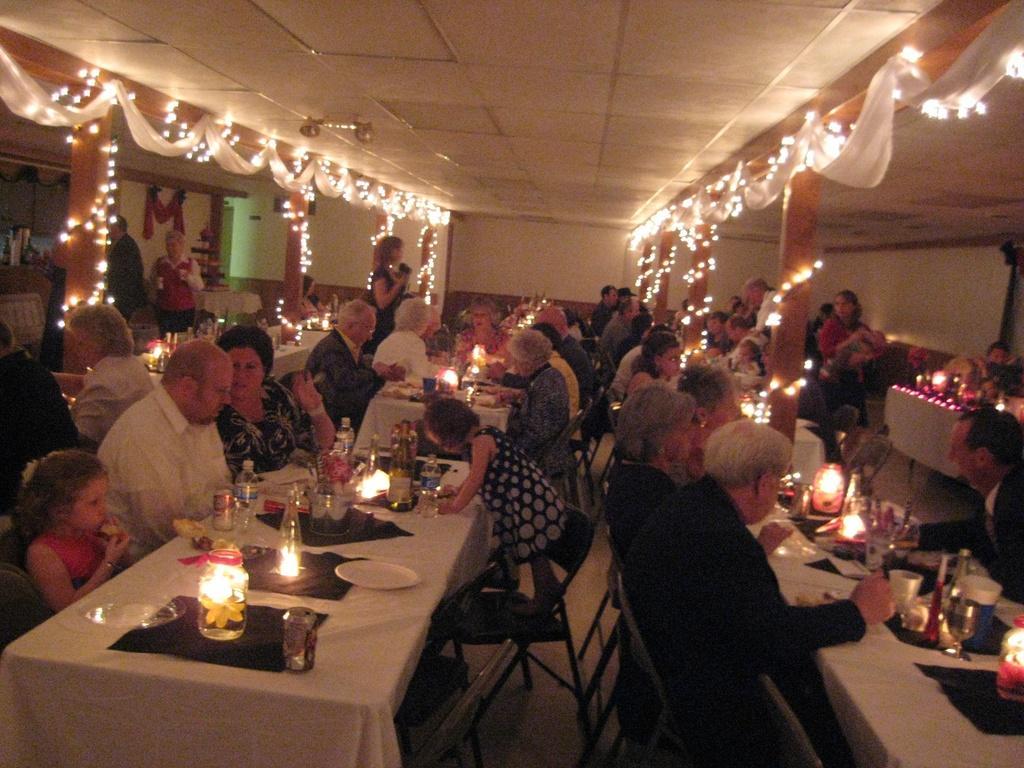How would you summarize this image in a sentence or two? It is a restaurant,it is beautifully decorated with a lot of lights and many people are sitting around the tables and having food. There are some pillars in between the tables they are also roped up with the lights,in the background there is a wall. 